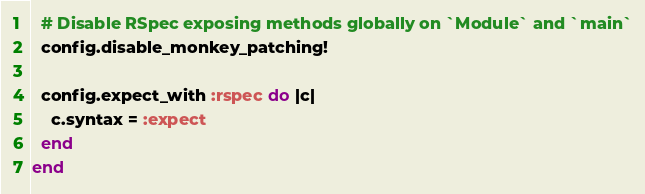Convert code to text. <code><loc_0><loc_0><loc_500><loc_500><_Ruby_>  # Disable RSpec exposing methods globally on `Module` and `main`
  config.disable_monkey_patching!

  config.expect_with :rspec do |c|
    c.syntax = :expect
  end
end
</code> 